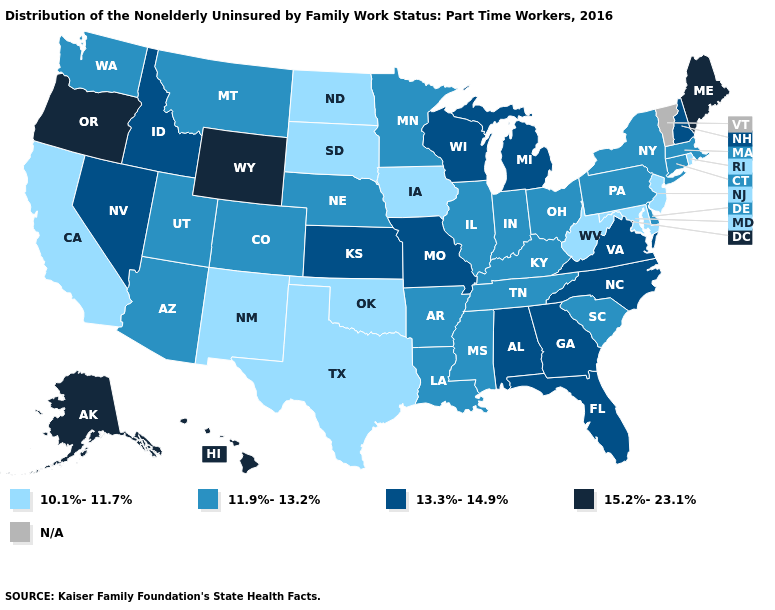Does Hawaii have the highest value in the USA?
Write a very short answer. Yes. Name the states that have a value in the range N/A?
Be succinct. Vermont. What is the value of Alabama?
Give a very brief answer. 13.3%-14.9%. What is the value of Oregon?
Answer briefly. 15.2%-23.1%. Does the map have missing data?
Give a very brief answer. Yes. Name the states that have a value in the range 10.1%-11.7%?
Keep it brief. California, Iowa, Maryland, New Jersey, New Mexico, North Dakota, Oklahoma, Rhode Island, South Dakota, Texas, West Virginia. Does New York have the highest value in the Northeast?
Be succinct. No. Does the first symbol in the legend represent the smallest category?
Give a very brief answer. Yes. What is the value of Montana?
Be succinct. 11.9%-13.2%. What is the highest value in the Northeast ?
Give a very brief answer. 15.2%-23.1%. What is the lowest value in states that border Oklahoma?
Short answer required. 10.1%-11.7%. Name the states that have a value in the range 15.2%-23.1%?
Be succinct. Alaska, Hawaii, Maine, Oregon, Wyoming. Name the states that have a value in the range 11.9%-13.2%?
Quick response, please. Arizona, Arkansas, Colorado, Connecticut, Delaware, Illinois, Indiana, Kentucky, Louisiana, Massachusetts, Minnesota, Mississippi, Montana, Nebraska, New York, Ohio, Pennsylvania, South Carolina, Tennessee, Utah, Washington. 